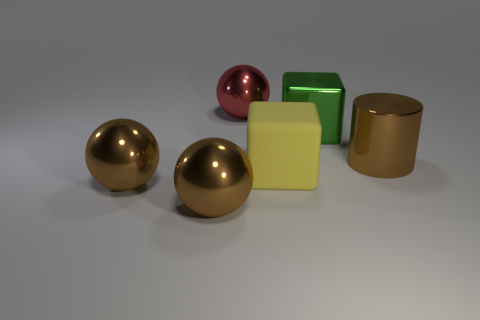How many tiny things are either spheres or brown cylinders?
Your answer should be compact. 0. How many other objects are there of the same color as the large cylinder?
Offer a terse response. 2. How many big brown metal objects are on the left side of the big cube that is behind the brown metal thing right of the large red shiny ball?
Your response must be concise. 2. Does the thing that is to the right of the green shiny object have the same size as the green thing?
Your answer should be compact. Yes. Are there fewer yellow rubber things on the right side of the large brown metal cylinder than large cubes that are in front of the metal cube?
Offer a very short reply. Yes. Are there fewer matte cubes behind the large red shiny sphere than big green objects?
Give a very brief answer. Yes. Do the yellow thing and the large cylinder have the same material?
Make the answer very short. No. How many brown things are made of the same material as the cylinder?
Give a very brief answer. 2. What is the color of the big block that is the same material as the big cylinder?
Give a very brief answer. Green. What is the shape of the yellow rubber object?
Make the answer very short. Cube. 